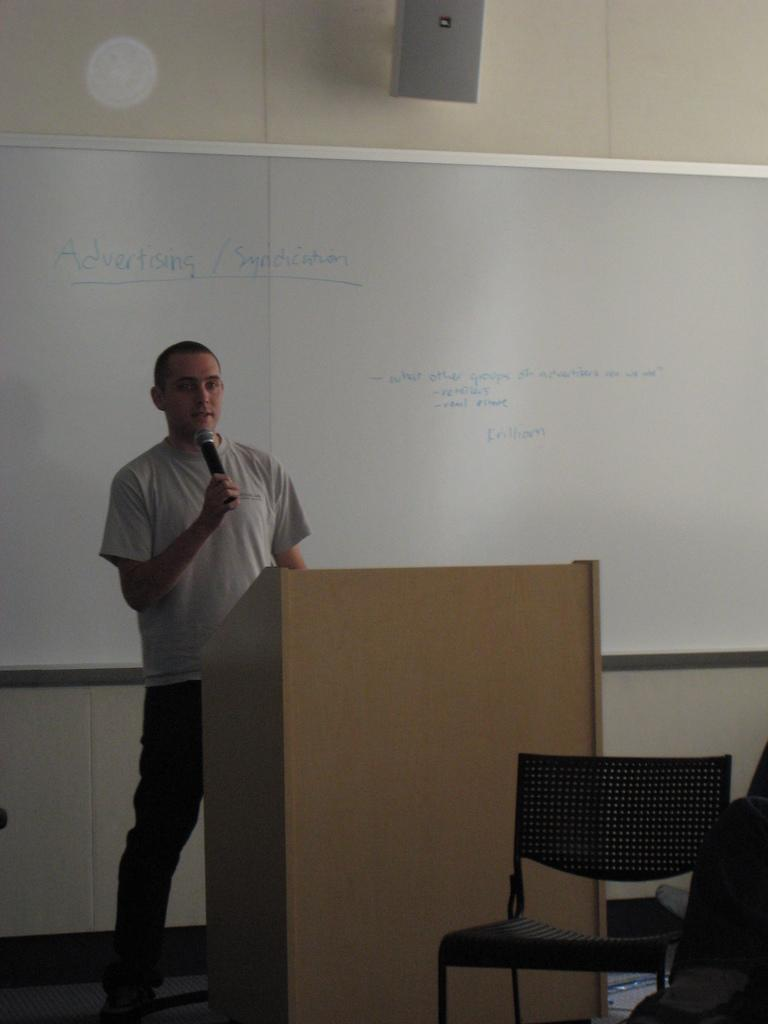What is the man in the image doing? The man is standing at a podium and speaking. What is the man holding in the image? The man is holding a microphone. What piece of furniture is present in the image? There is a chair in the image. What is on the wall in the image? There is a whiteboard on the wall. What type of stocking is the minister wearing in the image? There is no minister or stocking present in the image. What impulse might the man have to suddenly jump off the podium? There is no information about the man's impulses or intentions in the image, so it cannot be determined. 